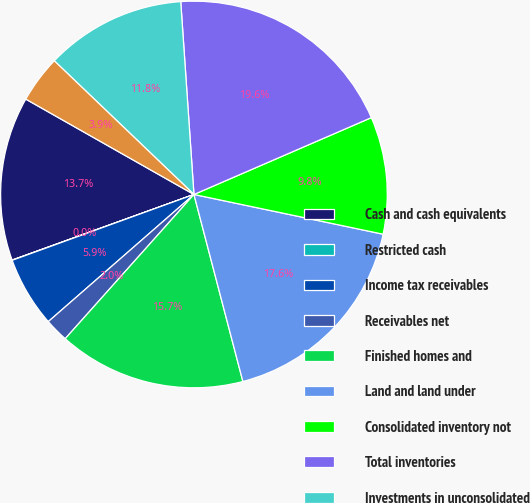<chart> <loc_0><loc_0><loc_500><loc_500><pie_chart><fcel>Cash and cash equivalents<fcel>Restricted cash<fcel>Income tax receivables<fcel>Receivables net<fcel>Finished homes and<fcel>Land and land under<fcel>Consolidated inventory not<fcel>Total inventories<fcel>Investments in unconsolidated<fcel>Other assets<nl><fcel>13.72%<fcel>0.02%<fcel>5.89%<fcel>1.98%<fcel>15.67%<fcel>17.63%<fcel>9.8%<fcel>19.58%<fcel>11.76%<fcel>3.94%<nl></chart> 